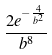Convert formula to latex. <formula><loc_0><loc_0><loc_500><loc_500>\frac { 2 e ^ { - \frac { 4 } { b ^ { 2 } } } } { b ^ { 8 } }</formula> 